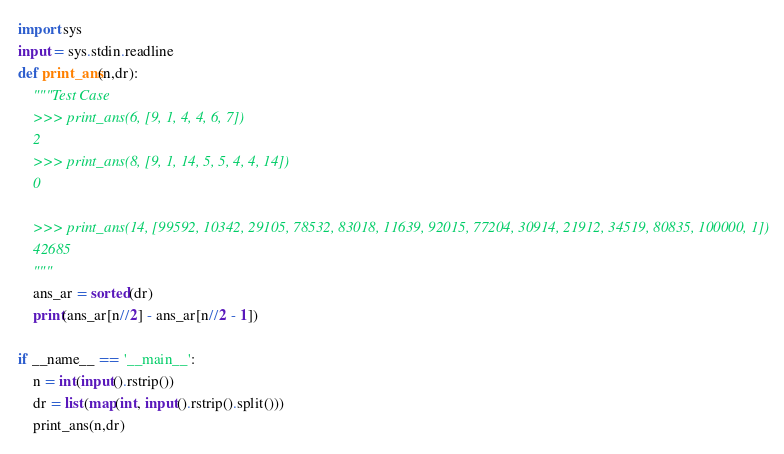<code> <loc_0><loc_0><loc_500><loc_500><_Python_>import sys
input = sys.stdin.readline
def print_ans(n,dr):
    """Test Case
    >>> print_ans(6, [9, 1, 4, 4, 6, 7])
    2
    >>> print_ans(8, [9, 1, 14, 5, 5, 4, 4, 14])
    0

    >>> print_ans(14, [99592, 10342, 29105, 78532, 83018, 11639, 92015, 77204, 30914, 21912, 34519, 80835, 100000, 1])
    42685
    """
    ans_ar = sorted(dr)
    print(ans_ar[n//2] - ans_ar[n//2 - 1])

if __name__ == '__main__':
    n = int(input().rstrip())
    dr = list(map(int, input().rstrip().split()))
    print_ans(n,dr)


</code> 